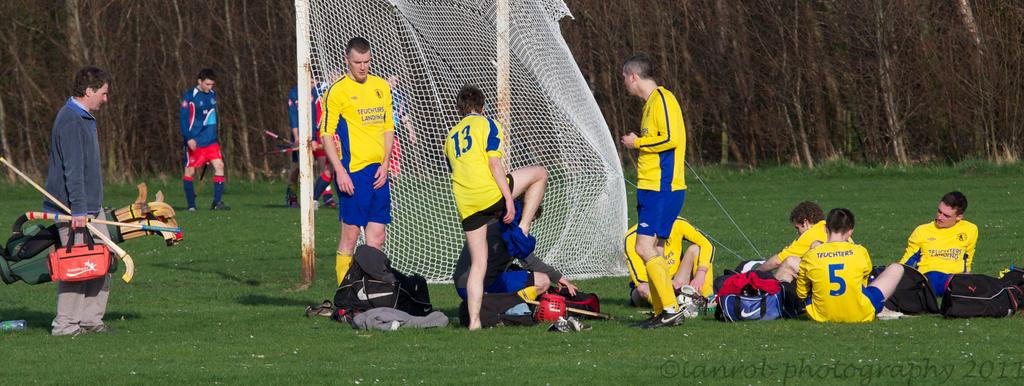What's the number of the player taking his pants off?
Make the answer very short. 13. The number is thirteen?
Ensure brevity in your answer.  Yes. 